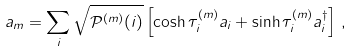<formula> <loc_0><loc_0><loc_500><loc_500>a _ { m } = \sum _ { i } \sqrt { \mathcal { P } ^ { ( m ) } ( i ) } \left [ \cosh \tau ^ { ( m ) } _ { i } a _ { i } + \sinh \tau ^ { ( m ) } _ { i } a _ { i } ^ { \dagger } \right ] \, ,</formula> 